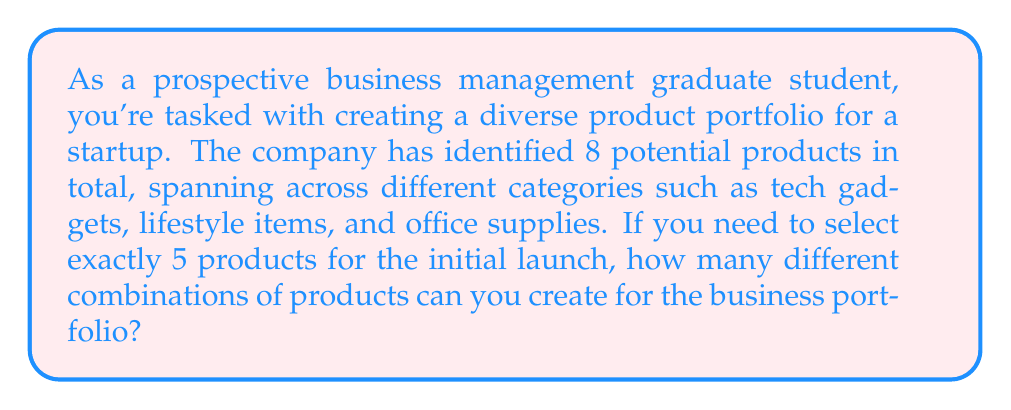Could you help me with this problem? To solve this problem, we need to use the combination formula. This is because:
1. The order of selection doesn't matter (combinations, not permutations).
2. We are selecting a subset from a larger set.
3. Each product can only be selected once.

The combination formula is:

$$ C(n,r) = \binom{n}{r} = \frac{n!}{r!(n-r)!} $$

Where:
- $n$ is the total number of items to choose from (in this case, 8 products)
- $r$ is the number of items being chosen (in this case, 5 products)

Let's plug in our values:

$$ C(8,5) = \binom{8}{5} = \frac{8!}{5!(8-5)!} = \frac{8!}{5!(3)!} $$

Now, let's calculate this step-by-step:

1) $8! = 8 \times 7 \times 6 \times 5 \times 4 \times 3 \times 2 \times 1 = 40,320$
2) $5! = 5 \times 4 \times 3 \times 2 \times 1 = 120$
3) $3! = 3 \times 2 \times 1 = 6$

Substituting these values:

$$ \frac{40,320}{120 \times 6} = \frac{40,320}{720} = 56 $$

Therefore, there are 56 different possible combinations of 5 products that can be selected from the 8 available products.
Answer: 56 combinations 